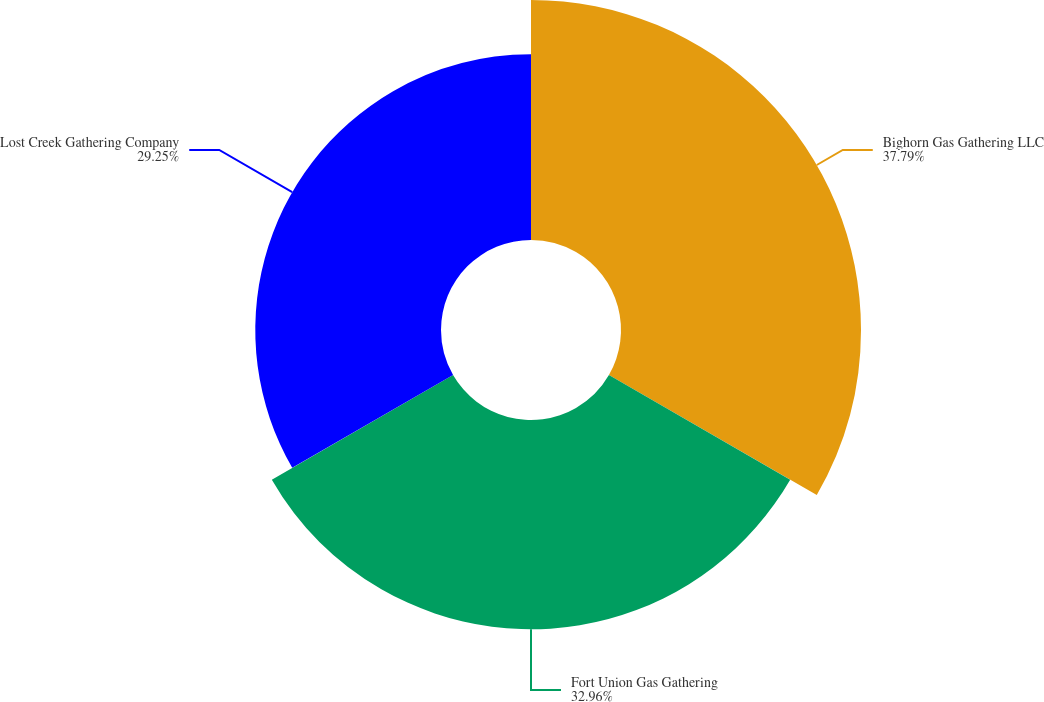Convert chart. <chart><loc_0><loc_0><loc_500><loc_500><pie_chart><fcel>Bighorn Gas Gathering LLC<fcel>Fort Union Gas Gathering<fcel>Lost Creek Gathering Company<nl><fcel>37.8%<fcel>32.96%<fcel>29.25%<nl></chart> 